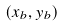Convert formula to latex. <formula><loc_0><loc_0><loc_500><loc_500>( x _ { b } , y _ { b } )</formula> 